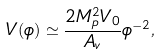Convert formula to latex. <formula><loc_0><loc_0><loc_500><loc_500>V ( \phi ) \simeq \frac { 2 M _ { p } ^ { 2 } V _ { 0 } } { A _ { v } } \phi ^ { - 2 } ,</formula> 